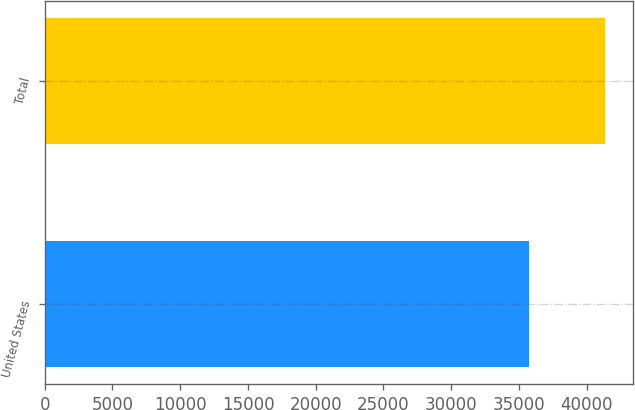Convert chart to OTSL. <chart><loc_0><loc_0><loc_500><loc_500><bar_chart><fcel>United States<fcel>Total<nl><fcel>35715<fcel>41373<nl></chart> 